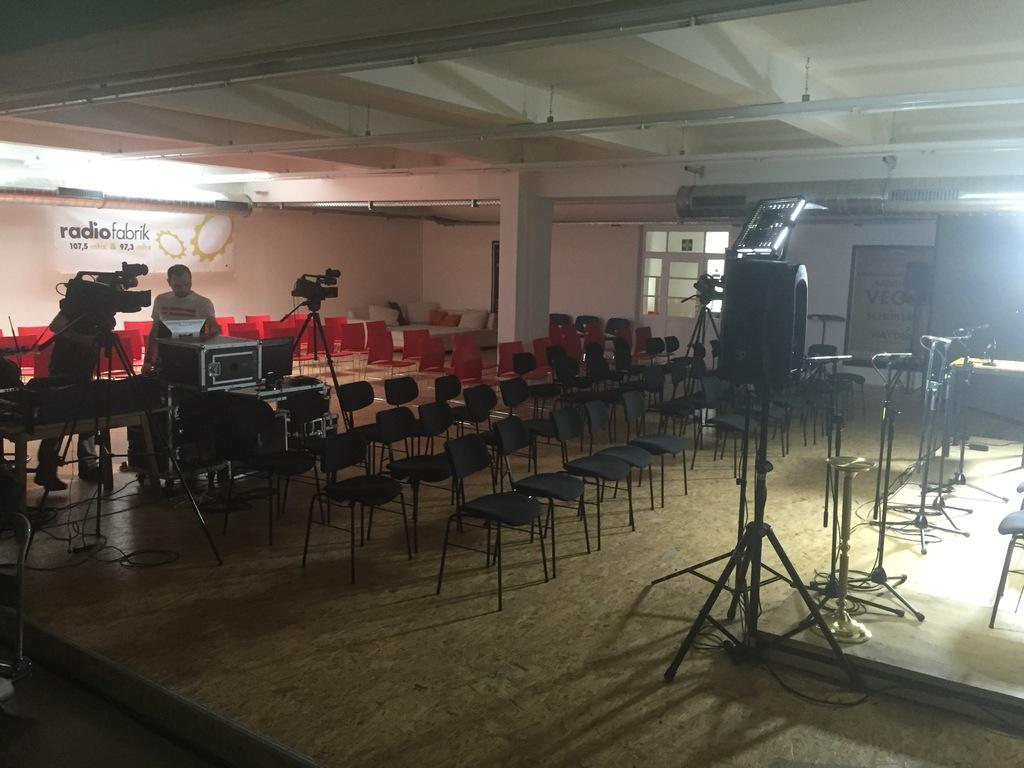Where was the image taken? The image was taken inside a room. What can be seen in the middle of the room? There are chairs in the middle of the room. What is located on the right side of the room? There is a stage on the right side of the room. Who is on the stage? There are people (miles) on the stage. What is present on the left side of the room? There are cameras on the left side of the room. What type of metal is used to construct the basin in the image? There is no basin present in the image. Can you describe the plane that is flying in the image? There is no plane visible in the image. 